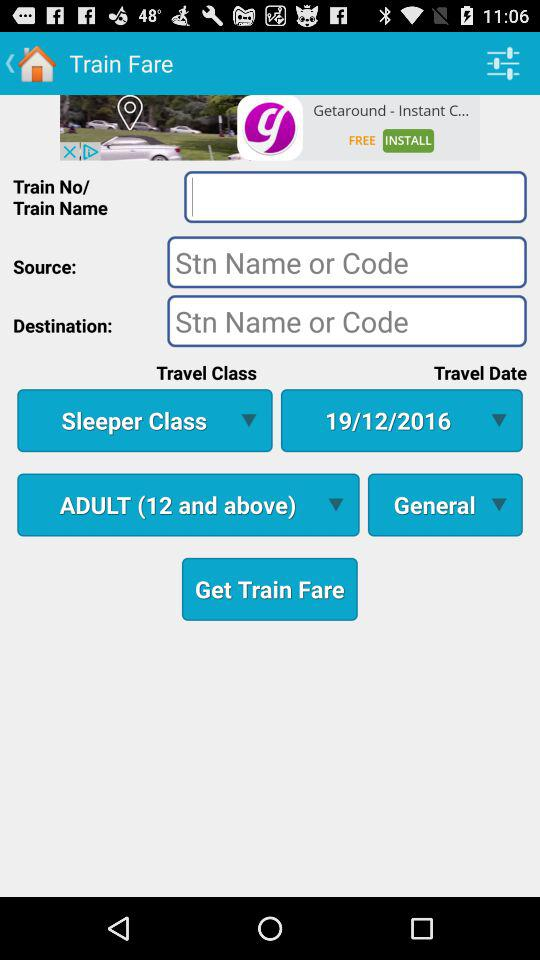What is the age criteria for an adult? The age criteria for an adult is "12 and above". 